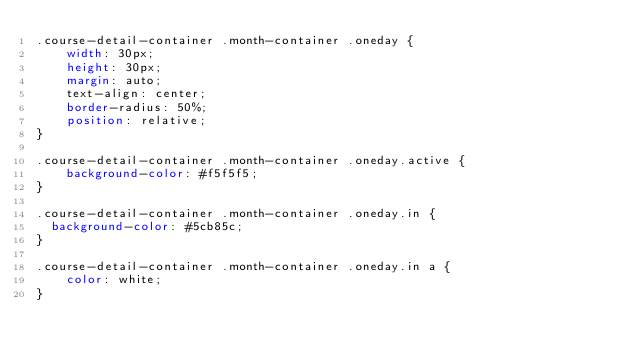Convert code to text. <code><loc_0><loc_0><loc_500><loc_500><_CSS_>.course-detail-container .month-container .oneday {
	width: 30px;
	height: 30px;
	margin: auto;
	text-align: center;
	border-radius: 50%;
	position: relative;
}

.course-detail-container .month-container .oneday.active {
	background-color: #f5f5f5;
}

.course-detail-container .month-container .oneday.in {
  background-color: #5cb85c;
}

.course-detail-container .month-container .oneday.in a {
	color: white;
}
</code> 